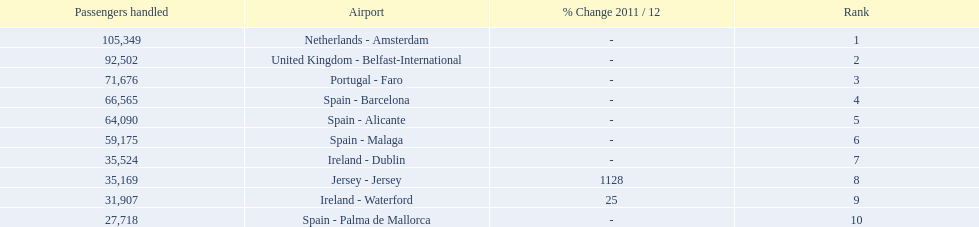What are all the airports in the top 10 busiest routes to and from london southend airport? Netherlands - Amsterdam, United Kingdom - Belfast-International, Portugal - Faro, Spain - Barcelona, Spain - Alicante, Spain - Malaga, Ireland - Dublin, Jersey - Jersey, Ireland - Waterford, Spain - Palma de Mallorca. Which airports are in portugal? Portugal - Faro. Could you parse the entire table? {'header': ['Passengers handled', 'Airport', '% Change 2011 / 12', 'Rank'], 'rows': [['105,349', 'Netherlands - Amsterdam', '-', '1'], ['92,502', 'United Kingdom - Belfast-International', '-', '2'], ['71,676', 'Portugal - Faro', '-', '3'], ['66,565', 'Spain - Barcelona', '-', '4'], ['64,090', 'Spain - Alicante', '-', '5'], ['59,175', 'Spain - Malaga', '-', '6'], ['35,524', 'Ireland - Dublin', '-', '7'], ['35,169', 'Jersey - Jersey', '1128', '8'], ['31,907', 'Ireland - Waterford', '25', '9'], ['27,718', 'Spain - Palma de Mallorca', '-', '10']]} 